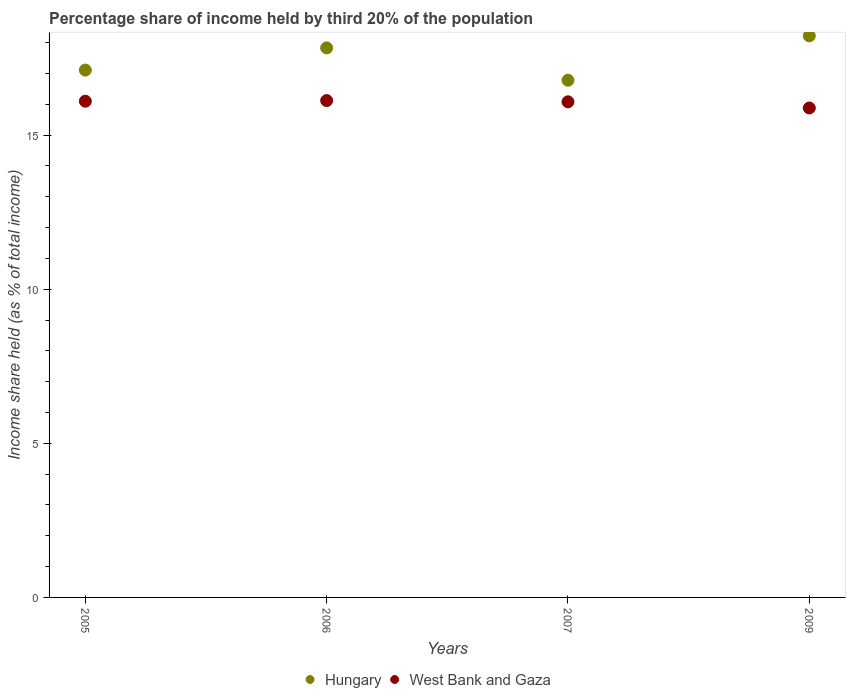How many different coloured dotlines are there?
Your response must be concise. 2. What is the share of income held by third 20% of the population in West Bank and Gaza in 2005?
Keep it short and to the point. 16.1. Across all years, what is the maximum share of income held by third 20% of the population in Hungary?
Your response must be concise. 18.22. Across all years, what is the minimum share of income held by third 20% of the population in Hungary?
Provide a short and direct response. 16.78. In which year was the share of income held by third 20% of the population in West Bank and Gaza maximum?
Provide a short and direct response. 2006. In which year was the share of income held by third 20% of the population in Hungary minimum?
Keep it short and to the point. 2007. What is the total share of income held by third 20% of the population in West Bank and Gaza in the graph?
Give a very brief answer. 64.18. What is the difference between the share of income held by third 20% of the population in West Bank and Gaza in 2005 and that in 2007?
Ensure brevity in your answer.  0.02. What is the difference between the share of income held by third 20% of the population in West Bank and Gaza in 2005 and the share of income held by third 20% of the population in Hungary in 2007?
Give a very brief answer. -0.68. What is the average share of income held by third 20% of the population in West Bank and Gaza per year?
Provide a short and direct response. 16.04. In the year 2005, what is the difference between the share of income held by third 20% of the population in West Bank and Gaza and share of income held by third 20% of the population in Hungary?
Provide a short and direct response. -1.01. What is the ratio of the share of income held by third 20% of the population in Hungary in 2006 to that in 2009?
Your response must be concise. 0.98. Is the share of income held by third 20% of the population in West Bank and Gaza in 2006 less than that in 2009?
Give a very brief answer. No. Is the difference between the share of income held by third 20% of the population in West Bank and Gaza in 2005 and 2009 greater than the difference between the share of income held by third 20% of the population in Hungary in 2005 and 2009?
Offer a terse response. Yes. What is the difference between the highest and the second highest share of income held by third 20% of the population in West Bank and Gaza?
Your response must be concise. 0.02. What is the difference between the highest and the lowest share of income held by third 20% of the population in West Bank and Gaza?
Your answer should be very brief. 0.24. In how many years, is the share of income held by third 20% of the population in West Bank and Gaza greater than the average share of income held by third 20% of the population in West Bank and Gaza taken over all years?
Ensure brevity in your answer.  3. Is the sum of the share of income held by third 20% of the population in West Bank and Gaza in 2005 and 2007 greater than the maximum share of income held by third 20% of the population in Hungary across all years?
Ensure brevity in your answer.  Yes. Does the share of income held by third 20% of the population in Hungary monotonically increase over the years?
Provide a succinct answer. No. Is the share of income held by third 20% of the population in Hungary strictly less than the share of income held by third 20% of the population in West Bank and Gaza over the years?
Offer a terse response. No. How many years are there in the graph?
Your answer should be very brief. 4. Does the graph contain any zero values?
Offer a terse response. No. Where does the legend appear in the graph?
Make the answer very short. Bottom center. How many legend labels are there?
Make the answer very short. 2. What is the title of the graph?
Your answer should be compact. Percentage share of income held by third 20% of the population. What is the label or title of the X-axis?
Your answer should be compact. Years. What is the label or title of the Y-axis?
Give a very brief answer. Income share held (as % of total income). What is the Income share held (as % of total income) of Hungary in 2005?
Your response must be concise. 17.11. What is the Income share held (as % of total income) of West Bank and Gaza in 2005?
Ensure brevity in your answer.  16.1. What is the Income share held (as % of total income) in Hungary in 2006?
Offer a very short reply. 17.83. What is the Income share held (as % of total income) of West Bank and Gaza in 2006?
Your answer should be very brief. 16.12. What is the Income share held (as % of total income) in Hungary in 2007?
Keep it short and to the point. 16.78. What is the Income share held (as % of total income) in West Bank and Gaza in 2007?
Make the answer very short. 16.08. What is the Income share held (as % of total income) of Hungary in 2009?
Provide a succinct answer. 18.22. What is the Income share held (as % of total income) in West Bank and Gaza in 2009?
Make the answer very short. 15.88. Across all years, what is the maximum Income share held (as % of total income) of Hungary?
Your answer should be compact. 18.22. Across all years, what is the maximum Income share held (as % of total income) in West Bank and Gaza?
Provide a short and direct response. 16.12. Across all years, what is the minimum Income share held (as % of total income) in Hungary?
Your response must be concise. 16.78. Across all years, what is the minimum Income share held (as % of total income) in West Bank and Gaza?
Offer a terse response. 15.88. What is the total Income share held (as % of total income) of Hungary in the graph?
Make the answer very short. 69.94. What is the total Income share held (as % of total income) in West Bank and Gaza in the graph?
Ensure brevity in your answer.  64.18. What is the difference between the Income share held (as % of total income) of Hungary in 2005 and that in 2006?
Give a very brief answer. -0.72. What is the difference between the Income share held (as % of total income) of West Bank and Gaza in 2005 and that in 2006?
Make the answer very short. -0.02. What is the difference between the Income share held (as % of total income) in Hungary in 2005 and that in 2007?
Provide a succinct answer. 0.33. What is the difference between the Income share held (as % of total income) in West Bank and Gaza in 2005 and that in 2007?
Give a very brief answer. 0.02. What is the difference between the Income share held (as % of total income) of Hungary in 2005 and that in 2009?
Your answer should be very brief. -1.11. What is the difference between the Income share held (as % of total income) of West Bank and Gaza in 2005 and that in 2009?
Provide a succinct answer. 0.22. What is the difference between the Income share held (as % of total income) in Hungary in 2006 and that in 2007?
Offer a very short reply. 1.05. What is the difference between the Income share held (as % of total income) of Hungary in 2006 and that in 2009?
Your response must be concise. -0.39. What is the difference between the Income share held (as % of total income) of West Bank and Gaza in 2006 and that in 2009?
Make the answer very short. 0.24. What is the difference between the Income share held (as % of total income) in Hungary in 2007 and that in 2009?
Give a very brief answer. -1.44. What is the difference between the Income share held (as % of total income) in West Bank and Gaza in 2007 and that in 2009?
Provide a succinct answer. 0.2. What is the difference between the Income share held (as % of total income) in Hungary in 2005 and the Income share held (as % of total income) in West Bank and Gaza in 2006?
Offer a terse response. 0.99. What is the difference between the Income share held (as % of total income) in Hungary in 2005 and the Income share held (as % of total income) in West Bank and Gaza in 2007?
Give a very brief answer. 1.03. What is the difference between the Income share held (as % of total income) in Hungary in 2005 and the Income share held (as % of total income) in West Bank and Gaza in 2009?
Provide a succinct answer. 1.23. What is the difference between the Income share held (as % of total income) in Hungary in 2006 and the Income share held (as % of total income) in West Bank and Gaza in 2009?
Ensure brevity in your answer.  1.95. What is the average Income share held (as % of total income) of Hungary per year?
Your answer should be very brief. 17.48. What is the average Income share held (as % of total income) in West Bank and Gaza per year?
Your response must be concise. 16.05. In the year 2005, what is the difference between the Income share held (as % of total income) of Hungary and Income share held (as % of total income) of West Bank and Gaza?
Keep it short and to the point. 1.01. In the year 2006, what is the difference between the Income share held (as % of total income) in Hungary and Income share held (as % of total income) in West Bank and Gaza?
Provide a short and direct response. 1.71. In the year 2009, what is the difference between the Income share held (as % of total income) in Hungary and Income share held (as % of total income) in West Bank and Gaza?
Make the answer very short. 2.34. What is the ratio of the Income share held (as % of total income) of Hungary in 2005 to that in 2006?
Your answer should be very brief. 0.96. What is the ratio of the Income share held (as % of total income) of West Bank and Gaza in 2005 to that in 2006?
Provide a succinct answer. 1. What is the ratio of the Income share held (as % of total income) in Hungary in 2005 to that in 2007?
Offer a terse response. 1.02. What is the ratio of the Income share held (as % of total income) of West Bank and Gaza in 2005 to that in 2007?
Ensure brevity in your answer.  1. What is the ratio of the Income share held (as % of total income) in Hungary in 2005 to that in 2009?
Your answer should be very brief. 0.94. What is the ratio of the Income share held (as % of total income) of West Bank and Gaza in 2005 to that in 2009?
Give a very brief answer. 1.01. What is the ratio of the Income share held (as % of total income) of Hungary in 2006 to that in 2007?
Offer a terse response. 1.06. What is the ratio of the Income share held (as % of total income) in West Bank and Gaza in 2006 to that in 2007?
Your response must be concise. 1. What is the ratio of the Income share held (as % of total income) in Hungary in 2006 to that in 2009?
Make the answer very short. 0.98. What is the ratio of the Income share held (as % of total income) in West Bank and Gaza in 2006 to that in 2009?
Offer a very short reply. 1.02. What is the ratio of the Income share held (as % of total income) of Hungary in 2007 to that in 2009?
Ensure brevity in your answer.  0.92. What is the ratio of the Income share held (as % of total income) in West Bank and Gaza in 2007 to that in 2009?
Your response must be concise. 1.01. What is the difference between the highest and the second highest Income share held (as % of total income) in Hungary?
Your answer should be very brief. 0.39. What is the difference between the highest and the lowest Income share held (as % of total income) of Hungary?
Provide a short and direct response. 1.44. What is the difference between the highest and the lowest Income share held (as % of total income) of West Bank and Gaza?
Make the answer very short. 0.24. 